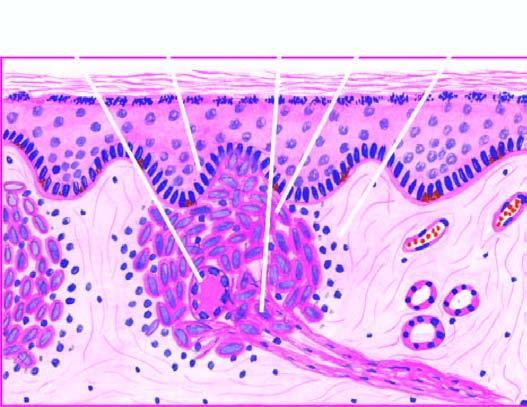s the granuloma composed of epithelioid cells with sparse langhans ' giant cells and lymphocytes?
Answer the question using a single word or phrase. Yes 